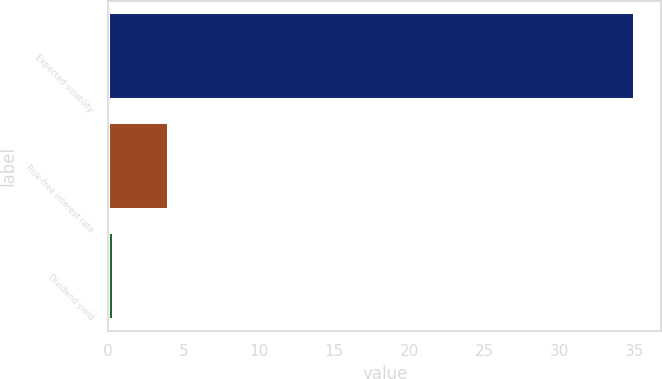Convert chart to OTSL. <chart><loc_0><loc_0><loc_500><loc_500><bar_chart><fcel>Expected volatility<fcel>Risk-free interest rate<fcel>Dividend yield<nl><fcel>35<fcel>4.02<fcel>0.38<nl></chart> 